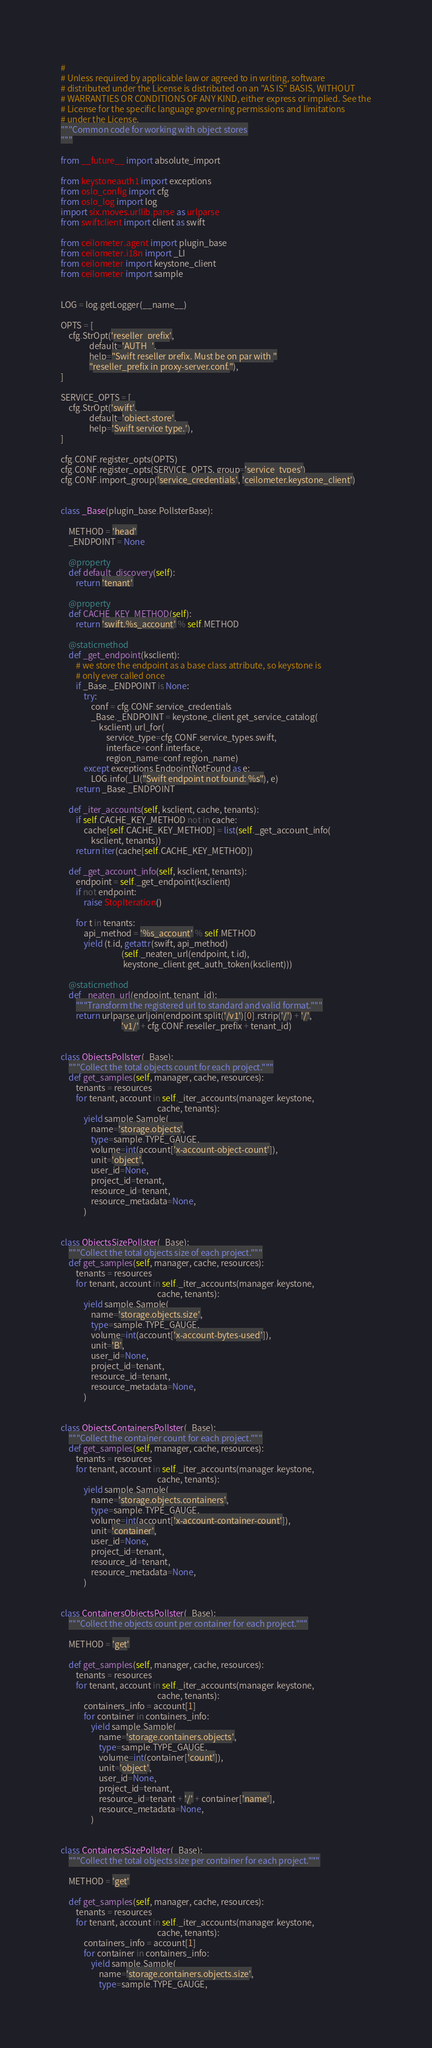<code> <loc_0><loc_0><loc_500><loc_500><_Python_>#
# Unless required by applicable law or agreed to in writing, software
# distributed under the License is distributed on an "AS IS" BASIS, WITHOUT
# WARRANTIES OR CONDITIONS OF ANY KIND, either express or implied. See the
# License for the specific language governing permissions and limitations
# under the License.
"""Common code for working with object stores
"""

from __future__ import absolute_import

from keystoneauth1 import exceptions
from oslo_config import cfg
from oslo_log import log
import six.moves.urllib.parse as urlparse
from swiftclient import client as swift

from ceilometer.agent import plugin_base
from ceilometer.i18n import _LI
from ceilometer import keystone_client
from ceilometer import sample


LOG = log.getLogger(__name__)

OPTS = [
    cfg.StrOpt('reseller_prefix',
               default='AUTH_',
               help="Swift reseller prefix. Must be on par with "
               "reseller_prefix in proxy-server.conf."),
]

SERVICE_OPTS = [
    cfg.StrOpt('swift',
               default='object-store',
               help='Swift service type.'),
]

cfg.CONF.register_opts(OPTS)
cfg.CONF.register_opts(SERVICE_OPTS, group='service_types')
cfg.CONF.import_group('service_credentials', 'ceilometer.keystone_client')


class _Base(plugin_base.PollsterBase):

    METHOD = 'head'
    _ENDPOINT = None

    @property
    def default_discovery(self):
        return 'tenant'

    @property
    def CACHE_KEY_METHOD(self):
        return 'swift.%s_account' % self.METHOD

    @staticmethod
    def _get_endpoint(ksclient):
        # we store the endpoint as a base class attribute, so keystone is
        # only ever called once
        if _Base._ENDPOINT is None:
            try:
                conf = cfg.CONF.service_credentials
                _Base._ENDPOINT = keystone_client.get_service_catalog(
                    ksclient).url_for(
                        service_type=cfg.CONF.service_types.swift,
                        interface=conf.interface,
                        region_name=conf.region_name)
            except exceptions.EndpointNotFound as e:
                LOG.info(_LI("Swift endpoint not found: %s"), e)
        return _Base._ENDPOINT

    def _iter_accounts(self, ksclient, cache, tenants):
        if self.CACHE_KEY_METHOD not in cache:
            cache[self.CACHE_KEY_METHOD] = list(self._get_account_info(
                ksclient, tenants))
        return iter(cache[self.CACHE_KEY_METHOD])

    def _get_account_info(self, ksclient, tenants):
        endpoint = self._get_endpoint(ksclient)
        if not endpoint:
            raise StopIteration()

        for t in tenants:
            api_method = '%s_account' % self.METHOD
            yield (t.id, getattr(swift, api_method)
                                (self._neaten_url(endpoint, t.id),
                                 keystone_client.get_auth_token(ksclient)))

    @staticmethod
    def _neaten_url(endpoint, tenant_id):
        """Transform the registered url to standard and valid format."""
        return urlparse.urljoin(endpoint.split('/v1')[0].rstrip('/') + '/',
                                'v1/' + cfg.CONF.reseller_prefix + tenant_id)


class ObjectsPollster(_Base):
    """Collect the total objects count for each project."""
    def get_samples(self, manager, cache, resources):
        tenants = resources
        for tenant, account in self._iter_accounts(manager.keystone,
                                                   cache, tenants):
            yield sample.Sample(
                name='storage.objects',
                type=sample.TYPE_GAUGE,
                volume=int(account['x-account-object-count']),
                unit='object',
                user_id=None,
                project_id=tenant,
                resource_id=tenant,
                resource_metadata=None,
            )


class ObjectsSizePollster(_Base):
    """Collect the total objects size of each project."""
    def get_samples(self, manager, cache, resources):
        tenants = resources
        for tenant, account in self._iter_accounts(manager.keystone,
                                                   cache, tenants):
            yield sample.Sample(
                name='storage.objects.size',
                type=sample.TYPE_GAUGE,
                volume=int(account['x-account-bytes-used']),
                unit='B',
                user_id=None,
                project_id=tenant,
                resource_id=tenant,
                resource_metadata=None,
            )


class ObjectsContainersPollster(_Base):
    """Collect the container count for each project."""
    def get_samples(self, manager, cache, resources):
        tenants = resources
        for tenant, account in self._iter_accounts(manager.keystone,
                                                   cache, tenants):
            yield sample.Sample(
                name='storage.objects.containers',
                type=sample.TYPE_GAUGE,
                volume=int(account['x-account-container-count']),
                unit='container',
                user_id=None,
                project_id=tenant,
                resource_id=tenant,
                resource_metadata=None,
            )


class ContainersObjectsPollster(_Base):
    """Collect the objects count per container for each project."""

    METHOD = 'get'

    def get_samples(self, manager, cache, resources):
        tenants = resources
        for tenant, account in self._iter_accounts(manager.keystone,
                                                   cache, tenants):
            containers_info = account[1]
            for container in containers_info:
                yield sample.Sample(
                    name='storage.containers.objects',
                    type=sample.TYPE_GAUGE,
                    volume=int(container['count']),
                    unit='object',
                    user_id=None,
                    project_id=tenant,
                    resource_id=tenant + '/' + container['name'],
                    resource_metadata=None,
                )


class ContainersSizePollster(_Base):
    """Collect the total objects size per container for each project."""

    METHOD = 'get'

    def get_samples(self, manager, cache, resources):
        tenants = resources
        for tenant, account in self._iter_accounts(manager.keystone,
                                                   cache, tenants):
            containers_info = account[1]
            for container in containers_info:
                yield sample.Sample(
                    name='storage.containers.objects.size',
                    type=sample.TYPE_GAUGE,</code> 